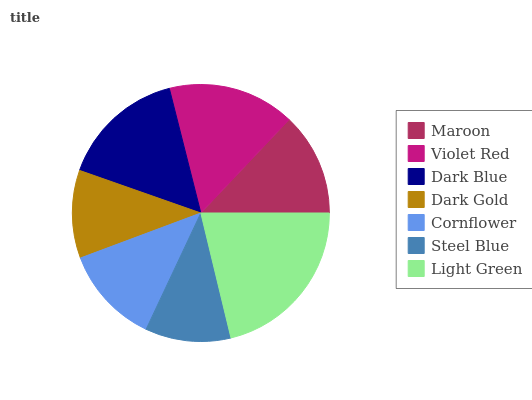Is Steel Blue the minimum?
Answer yes or no. Yes. Is Light Green the maximum?
Answer yes or no. Yes. Is Violet Red the minimum?
Answer yes or no. No. Is Violet Red the maximum?
Answer yes or no. No. Is Violet Red greater than Maroon?
Answer yes or no. Yes. Is Maroon less than Violet Red?
Answer yes or no. Yes. Is Maroon greater than Violet Red?
Answer yes or no. No. Is Violet Red less than Maroon?
Answer yes or no. No. Is Maroon the high median?
Answer yes or no. Yes. Is Maroon the low median?
Answer yes or no. Yes. Is Light Green the high median?
Answer yes or no. No. Is Cornflower the low median?
Answer yes or no. No. 